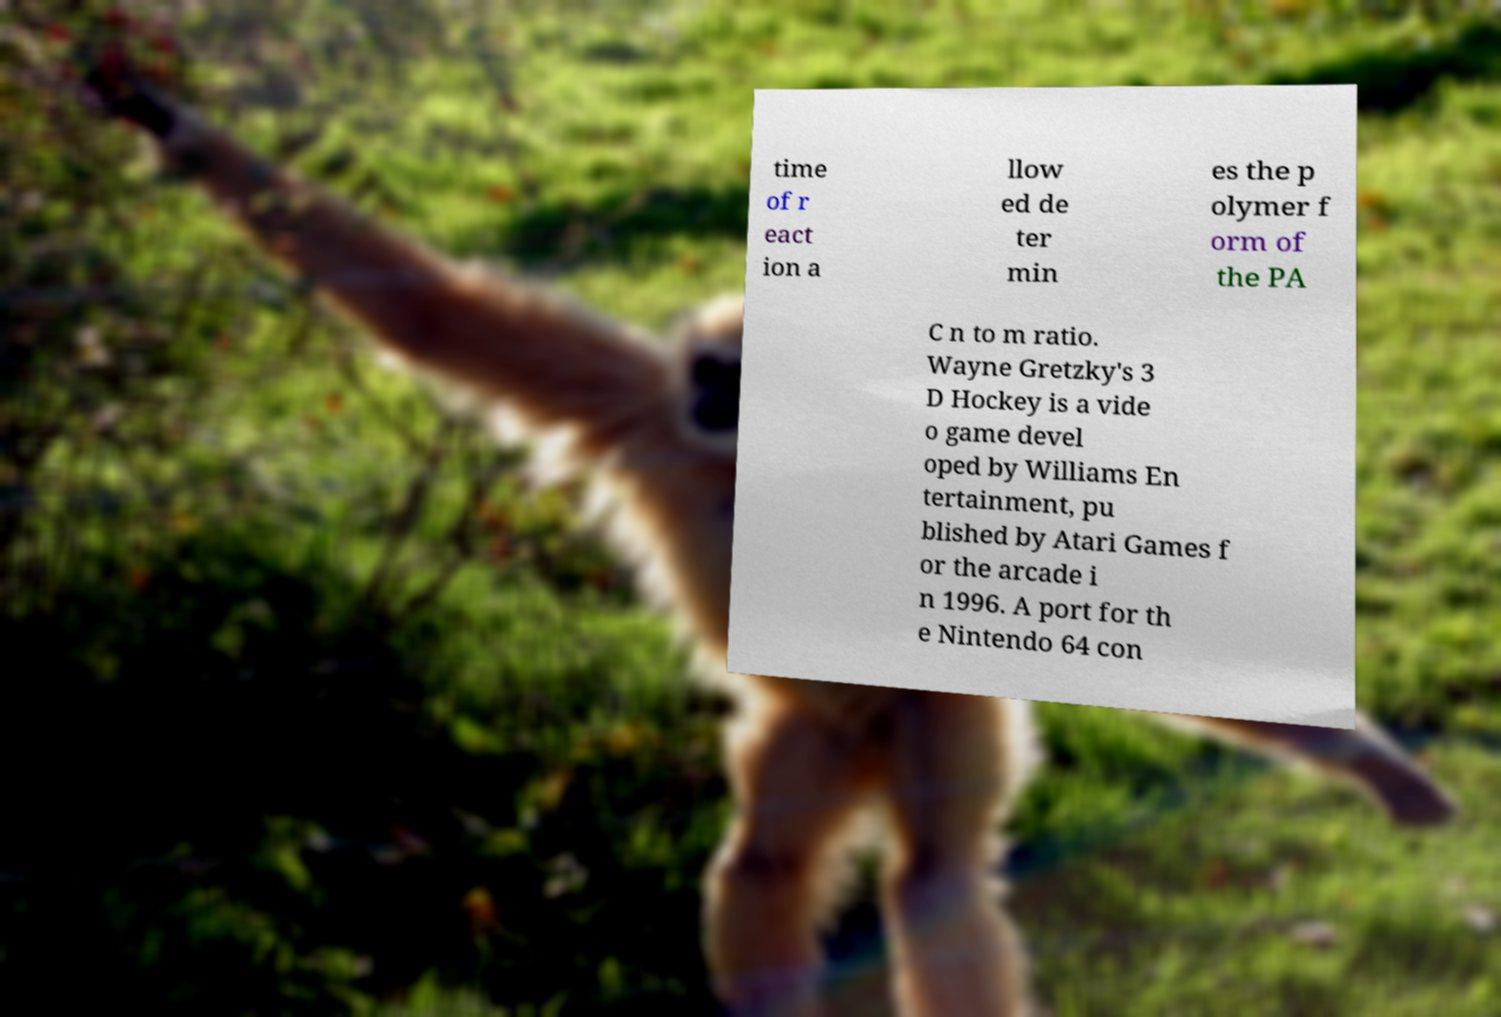Could you assist in decoding the text presented in this image and type it out clearly? time of r eact ion a llow ed de ter min es the p olymer f orm of the PA C n to m ratio. Wayne Gretzky's 3 D Hockey is a vide o game devel oped by Williams En tertainment, pu blished by Atari Games f or the arcade i n 1996. A port for th e Nintendo 64 con 